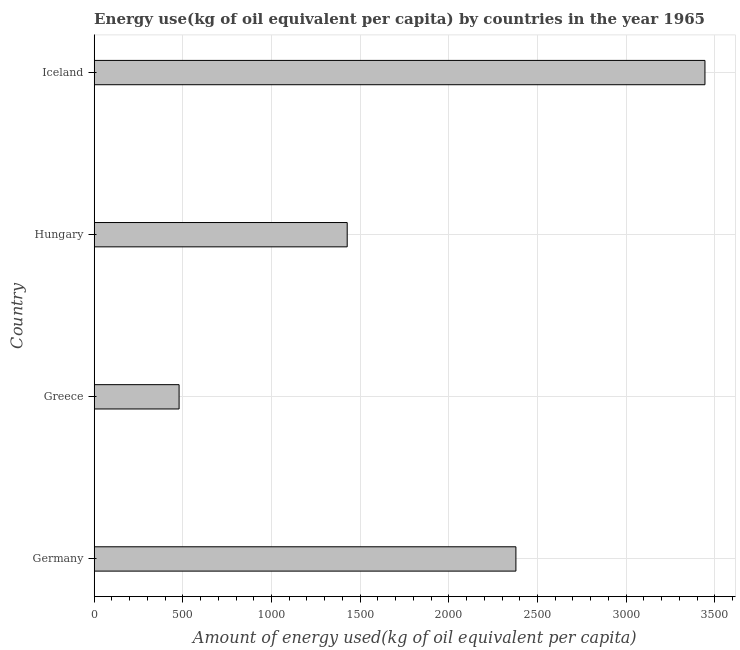Does the graph contain grids?
Offer a terse response. Yes. What is the title of the graph?
Your answer should be very brief. Energy use(kg of oil equivalent per capita) by countries in the year 1965. What is the label or title of the X-axis?
Your answer should be compact. Amount of energy used(kg of oil equivalent per capita). What is the label or title of the Y-axis?
Give a very brief answer. Country. What is the amount of energy used in Iceland?
Give a very brief answer. 3444.55. Across all countries, what is the maximum amount of energy used?
Your answer should be very brief. 3444.55. Across all countries, what is the minimum amount of energy used?
Give a very brief answer. 478.76. In which country was the amount of energy used maximum?
Your response must be concise. Iceland. In which country was the amount of energy used minimum?
Provide a short and direct response. Greece. What is the sum of the amount of energy used?
Provide a succinct answer. 7728.55. What is the difference between the amount of energy used in Germany and Iceland?
Provide a succinct answer. -1066.21. What is the average amount of energy used per country?
Provide a short and direct response. 1932.14. What is the median amount of energy used?
Offer a terse response. 1902.62. What is the ratio of the amount of energy used in Greece to that in Hungary?
Provide a short and direct response. 0.34. Is the amount of energy used in Greece less than that in Hungary?
Make the answer very short. Yes. Is the difference between the amount of energy used in Germany and Iceland greater than the difference between any two countries?
Your answer should be very brief. No. What is the difference between the highest and the second highest amount of energy used?
Offer a very short reply. 1066.21. Is the sum of the amount of energy used in Greece and Iceland greater than the maximum amount of energy used across all countries?
Offer a terse response. Yes. What is the difference between the highest and the lowest amount of energy used?
Offer a terse response. 2965.8. In how many countries, is the amount of energy used greater than the average amount of energy used taken over all countries?
Your answer should be very brief. 2. How many countries are there in the graph?
Offer a terse response. 4. What is the difference between two consecutive major ticks on the X-axis?
Your response must be concise. 500. What is the Amount of energy used(kg of oil equivalent per capita) in Germany?
Offer a terse response. 2378.34. What is the Amount of energy used(kg of oil equivalent per capita) in Greece?
Provide a succinct answer. 478.76. What is the Amount of energy used(kg of oil equivalent per capita) of Hungary?
Keep it short and to the point. 1426.9. What is the Amount of energy used(kg of oil equivalent per capita) of Iceland?
Make the answer very short. 3444.55. What is the difference between the Amount of energy used(kg of oil equivalent per capita) in Germany and Greece?
Your answer should be compact. 1899.58. What is the difference between the Amount of energy used(kg of oil equivalent per capita) in Germany and Hungary?
Give a very brief answer. 951.44. What is the difference between the Amount of energy used(kg of oil equivalent per capita) in Germany and Iceland?
Offer a terse response. -1066.21. What is the difference between the Amount of energy used(kg of oil equivalent per capita) in Greece and Hungary?
Your answer should be very brief. -948.14. What is the difference between the Amount of energy used(kg of oil equivalent per capita) in Greece and Iceland?
Your answer should be compact. -2965.8. What is the difference between the Amount of energy used(kg of oil equivalent per capita) in Hungary and Iceland?
Make the answer very short. -2017.65. What is the ratio of the Amount of energy used(kg of oil equivalent per capita) in Germany to that in Greece?
Your answer should be very brief. 4.97. What is the ratio of the Amount of energy used(kg of oil equivalent per capita) in Germany to that in Hungary?
Your answer should be very brief. 1.67. What is the ratio of the Amount of energy used(kg of oil equivalent per capita) in Germany to that in Iceland?
Your answer should be very brief. 0.69. What is the ratio of the Amount of energy used(kg of oil equivalent per capita) in Greece to that in Hungary?
Offer a very short reply. 0.34. What is the ratio of the Amount of energy used(kg of oil equivalent per capita) in Greece to that in Iceland?
Offer a terse response. 0.14. What is the ratio of the Amount of energy used(kg of oil equivalent per capita) in Hungary to that in Iceland?
Your answer should be compact. 0.41. 